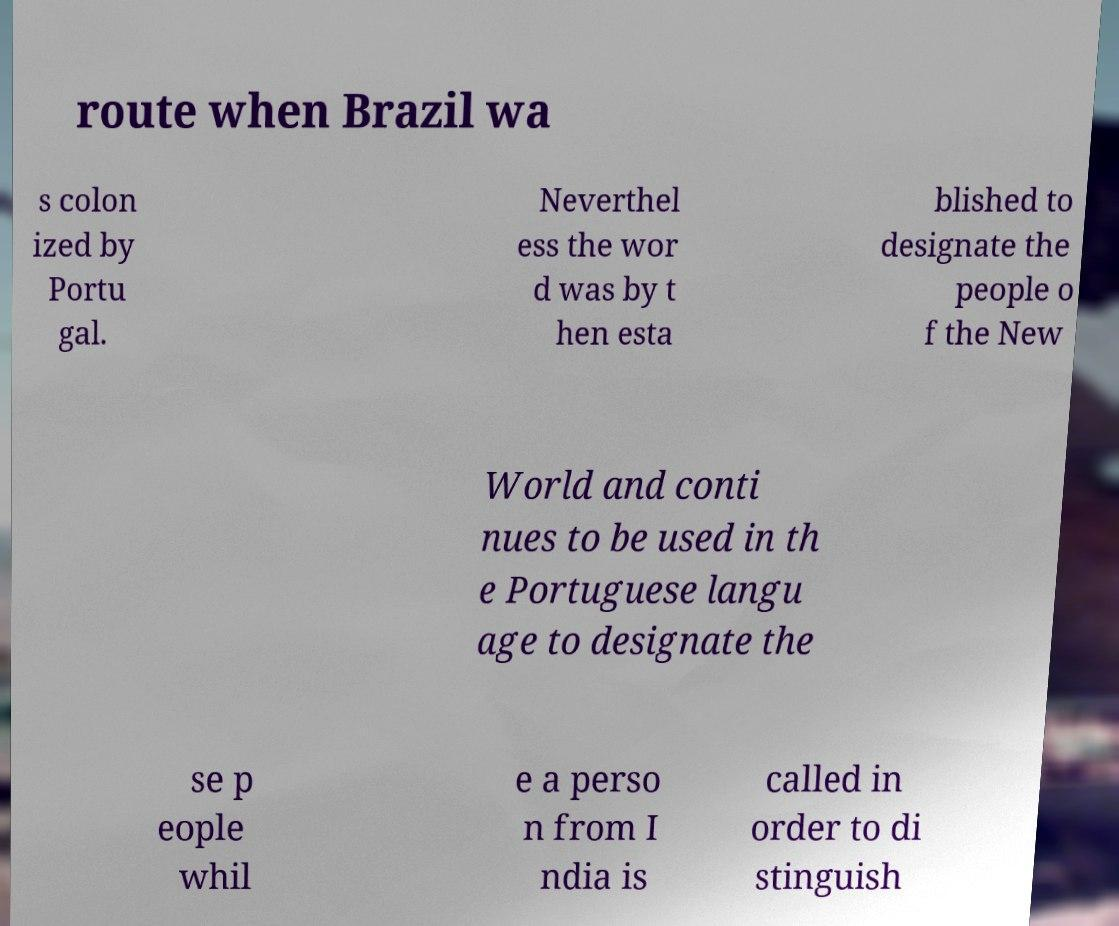For documentation purposes, I need the text within this image transcribed. Could you provide that? route when Brazil wa s colon ized by Portu gal. Neverthel ess the wor d was by t hen esta blished to designate the people o f the New World and conti nues to be used in th e Portuguese langu age to designate the se p eople whil e a perso n from I ndia is called in order to di stinguish 